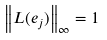<formula> <loc_0><loc_0><loc_500><loc_500>\left \| L ( e _ { j } ) \right \| _ { \infty } = 1</formula> 